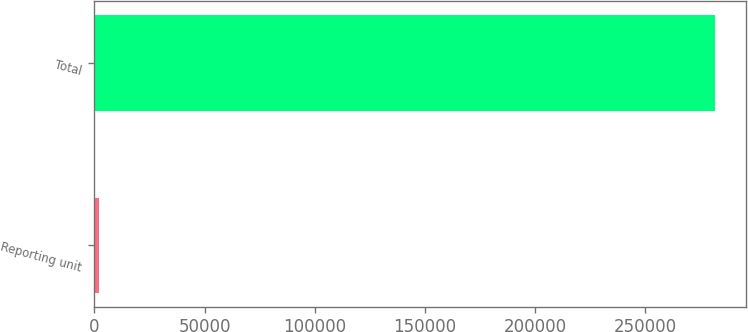<chart> <loc_0><loc_0><loc_500><loc_500><bar_chart><fcel>Reporting unit<fcel>Total<nl><fcel>2016<fcel>281415<nl></chart> 